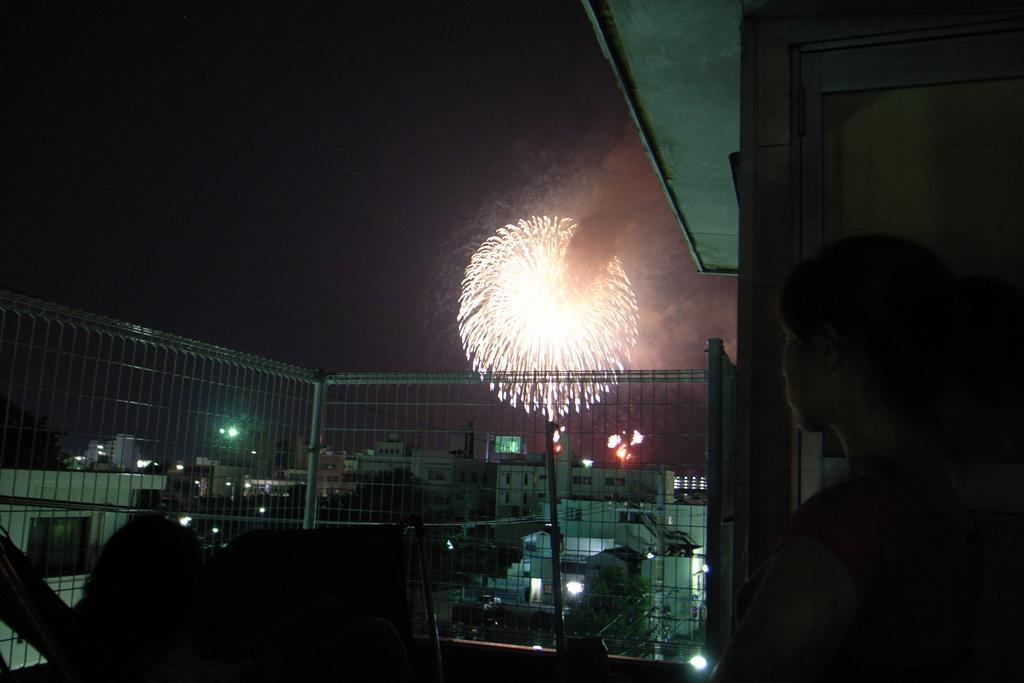Can you describe this image briefly? In this image in the front there are persons. In the center there is a fence, in the background there are buildings and there are lights and in the air there is a cracker burning. 